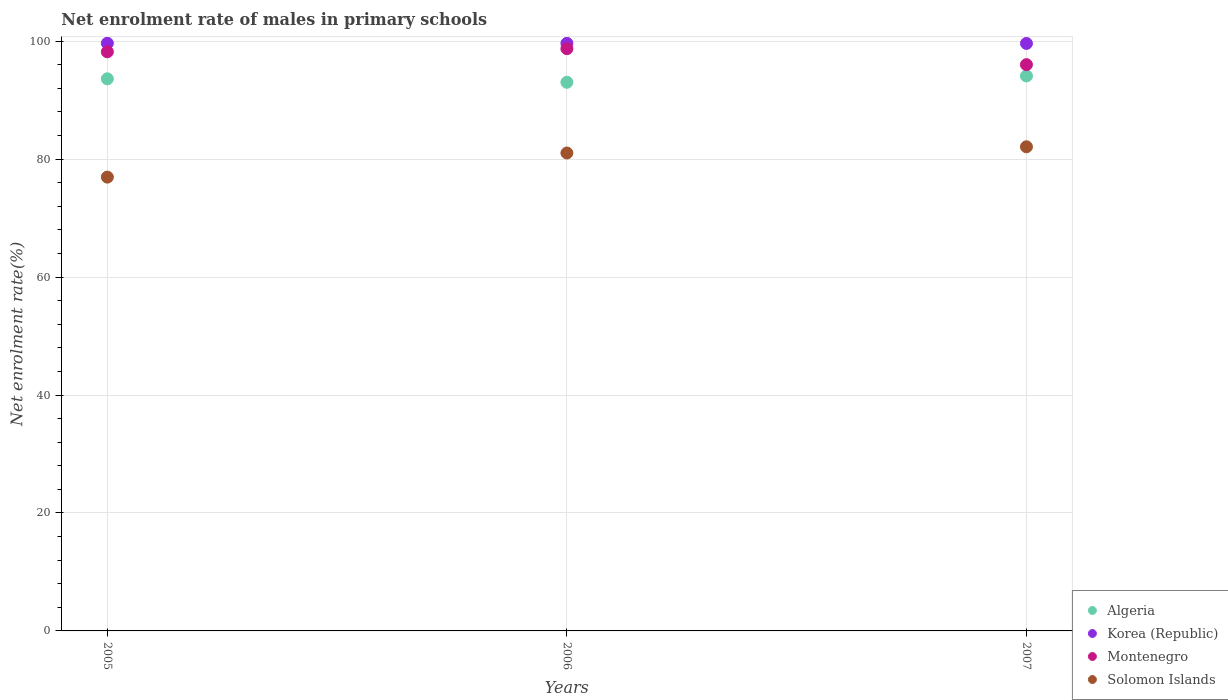How many different coloured dotlines are there?
Your answer should be very brief. 4. What is the net enrolment rate of males in primary schools in Algeria in 2006?
Ensure brevity in your answer.  93.03. Across all years, what is the maximum net enrolment rate of males in primary schools in Montenegro?
Keep it short and to the point. 98.73. Across all years, what is the minimum net enrolment rate of males in primary schools in Montenegro?
Make the answer very short. 96.02. In which year was the net enrolment rate of males in primary schools in Montenegro maximum?
Give a very brief answer. 2006. What is the total net enrolment rate of males in primary schools in Solomon Islands in the graph?
Offer a very short reply. 240.09. What is the difference between the net enrolment rate of males in primary schools in Solomon Islands in 2005 and that in 2006?
Your answer should be compact. -4.09. What is the difference between the net enrolment rate of males in primary schools in Algeria in 2006 and the net enrolment rate of males in primary schools in Solomon Islands in 2005?
Your answer should be very brief. 16.08. What is the average net enrolment rate of males in primary schools in Algeria per year?
Make the answer very short. 93.59. In the year 2006, what is the difference between the net enrolment rate of males in primary schools in Algeria and net enrolment rate of males in primary schools in Solomon Islands?
Make the answer very short. 11.99. In how many years, is the net enrolment rate of males in primary schools in Korea (Republic) greater than 20 %?
Your answer should be very brief. 3. What is the ratio of the net enrolment rate of males in primary schools in Korea (Republic) in 2005 to that in 2007?
Your answer should be very brief. 1. Is the net enrolment rate of males in primary schools in Algeria in 2005 less than that in 2006?
Offer a very short reply. No. Is the difference between the net enrolment rate of males in primary schools in Algeria in 2005 and 2007 greater than the difference between the net enrolment rate of males in primary schools in Solomon Islands in 2005 and 2007?
Offer a terse response. Yes. What is the difference between the highest and the second highest net enrolment rate of males in primary schools in Solomon Islands?
Make the answer very short. 1.05. What is the difference between the highest and the lowest net enrolment rate of males in primary schools in Korea (Republic)?
Provide a succinct answer. 0.03. Is the net enrolment rate of males in primary schools in Algeria strictly greater than the net enrolment rate of males in primary schools in Korea (Republic) over the years?
Offer a very short reply. No. Is the net enrolment rate of males in primary schools in Algeria strictly less than the net enrolment rate of males in primary schools in Montenegro over the years?
Make the answer very short. Yes. How many years are there in the graph?
Offer a very short reply. 3. How are the legend labels stacked?
Offer a very short reply. Vertical. What is the title of the graph?
Make the answer very short. Net enrolment rate of males in primary schools. Does "Heavily indebted poor countries" appear as one of the legend labels in the graph?
Give a very brief answer. No. What is the label or title of the Y-axis?
Offer a very short reply. Net enrolment rate(%). What is the Net enrolment rate(%) of Algeria in 2005?
Your answer should be compact. 93.62. What is the Net enrolment rate(%) in Korea (Republic) in 2005?
Provide a short and direct response. 99.65. What is the Net enrolment rate(%) in Montenegro in 2005?
Provide a short and direct response. 98.2. What is the Net enrolment rate(%) of Solomon Islands in 2005?
Your answer should be very brief. 76.95. What is the Net enrolment rate(%) in Algeria in 2006?
Make the answer very short. 93.03. What is the Net enrolment rate(%) in Korea (Republic) in 2006?
Your answer should be very brief. 99.64. What is the Net enrolment rate(%) of Montenegro in 2006?
Make the answer very short. 98.73. What is the Net enrolment rate(%) in Solomon Islands in 2006?
Ensure brevity in your answer.  81.04. What is the Net enrolment rate(%) of Algeria in 2007?
Keep it short and to the point. 94.11. What is the Net enrolment rate(%) in Korea (Republic) in 2007?
Offer a very short reply. 99.62. What is the Net enrolment rate(%) of Montenegro in 2007?
Your response must be concise. 96.02. What is the Net enrolment rate(%) in Solomon Islands in 2007?
Keep it short and to the point. 82.1. Across all years, what is the maximum Net enrolment rate(%) of Algeria?
Keep it short and to the point. 94.11. Across all years, what is the maximum Net enrolment rate(%) of Korea (Republic)?
Make the answer very short. 99.65. Across all years, what is the maximum Net enrolment rate(%) in Montenegro?
Make the answer very short. 98.73. Across all years, what is the maximum Net enrolment rate(%) of Solomon Islands?
Offer a very short reply. 82.1. Across all years, what is the minimum Net enrolment rate(%) of Algeria?
Your answer should be very brief. 93.03. Across all years, what is the minimum Net enrolment rate(%) of Korea (Republic)?
Your answer should be very brief. 99.62. Across all years, what is the minimum Net enrolment rate(%) of Montenegro?
Provide a short and direct response. 96.02. Across all years, what is the minimum Net enrolment rate(%) of Solomon Islands?
Provide a short and direct response. 76.95. What is the total Net enrolment rate(%) in Algeria in the graph?
Provide a short and direct response. 280.76. What is the total Net enrolment rate(%) of Korea (Republic) in the graph?
Ensure brevity in your answer.  298.91. What is the total Net enrolment rate(%) of Montenegro in the graph?
Offer a terse response. 292.96. What is the total Net enrolment rate(%) of Solomon Islands in the graph?
Give a very brief answer. 240.09. What is the difference between the Net enrolment rate(%) of Algeria in 2005 and that in 2006?
Your answer should be very brief. 0.59. What is the difference between the Net enrolment rate(%) of Korea (Republic) in 2005 and that in 2006?
Provide a succinct answer. 0.01. What is the difference between the Net enrolment rate(%) of Montenegro in 2005 and that in 2006?
Offer a very short reply. -0.53. What is the difference between the Net enrolment rate(%) of Solomon Islands in 2005 and that in 2006?
Keep it short and to the point. -4.09. What is the difference between the Net enrolment rate(%) in Algeria in 2005 and that in 2007?
Make the answer very short. -0.48. What is the difference between the Net enrolment rate(%) of Korea (Republic) in 2005 and that in 2007?
Provide a succinct answer. 0.03. What is the difference between the Net enrolment rate(%) of Montenegro in 2005 and that in 2007?
Ensure brevity in your answer.  2.18. What is the difference between the Net enrolment rate(%) of Solomon Islands in 2005 and that in 2007?
Provide a succinct answer. -5.14. What is the difference between the Net enrolment rate(%) of Algeria in 2006 and that in 2007?
Provide a succinct answer. -1.07. What is the difference between the Net enrolment rate(%) of Korea (Republic) in 2006 and that in 2007?
Provide a succinct answer. 0.02. What is the difference between the Net enrolment rate(%) in Montenegro in 2006 and that in 2007?
Offer a terse response. 2.71. What is the difference between the Net enrolment rate(%) in Solomon Islands in 2006 and that in 2007?
Your answer should be compact. -1.05. What is the difference between the Net enrolment rate(%) in Algeria in 2005 and the Net enrolment rate(%) in Korea (Republic) in 2006?
Provide a short and direct response. -6.02. What is the difference between the Net enrolment rate(%) of Algeria in 2005 and the Net enrolment rate(%) of Montenegro in 2006?
Your response must be concise. -5.11. What is the difference between the Net enrolment rate(%) of Algeria in 2005 and the Net enrolment rate(%) of Solomon Islands in 2006?
Your response must be concise. 12.58. What is the difference between the Net enrolment rate(%) in Korea (Republic) in 2005 and the Net enrolment rate(%) in Montenegro in 2006?
Your answer should be very brief. 0.91. What is the difference between the Net enrolment rate(%) of Korea (Republic) in 2005 and the Net enrolment rate(%) of Solomon Islands in 2006?
Your answer should be compact. 18.61. What is the difference between the Net enrolment rate(%) of Montenegro in 2005 and the Net enrolment rate(%) of Solomon Islands in 2006?
Give a very brief answer. 17.16. What is the difference between the Net enrolment rate(%) of Algeria in 2005 and the Net enrolment rate(%) of Korea (Republic) in 2007?
Offer a very short reply. -6. What is the difference between the Net enrolment rate(%) of Algeria in 2005 and the Net enrolment rate(%) of Montenegro in 2007?
Your answer should be compact. -2.4. What is the difference between the Net enrolment rate(%) of Algeria in 2005 and the Net enrolment rate(%) of Solomon Islands in 2007?
Offer a very short reply. 11.53. What is the difference between the Net enrolment rate(%) of Korea (Republic) in 2005 and the Net enrolment rate(%) of Montenegro in 2007?
Make the answer very short. 3.62. What is the difference between the Net enrolment rate(%) of Korea (Republic) in 2005 and the Net enrolment rate(%) of Solomon Islands in 2007?
Your response must be concise. 17.55. What is the difference between the Net enrolment rate(%) in Montenegro in 2005 and the Net enrolment rate(%) in Solomon Islands in 2007?
Offer a very short reply. 16.11. What is the difference between the Net enrolment rate(%) of Algeria in 2006 and the Net enrolment rate(%) of Korea (Republic) in 2007?
Give a very brief answer. -6.59. What is the difference between the Net enrolment rate(%) of Algeria in 2006 and the Net enrolment rate(%) of Montenegro in 2007?
Your response must be concise. -2.99. What is the difference between the Net enrolment rate(%) in Algeria in 2006 and the Net enrolment rate(%) in Solomon Islands in 2007?
Your response must be concise. 10.94. What is the difference between the Net enrolment rate(%) in Korea (Republic) in 2006 and the Net enrolment rate(%) in Montenegro in 2007?
Your answer should be very brief. 3.61. What is the difference between the Net enrolment rate(%) in Korea (Republic) in 2006 and the Net enrolment rate(%) in Solomon Islands in 2007?
Offer a terse response. 17.54. What is the difference between the Net enrolment rate(%) in Montenegro in 2006 and the Net enrolment rate(%) in Solomon Islands in 2007?
Your answer should be compact. 16.64. What is the average Net enrolment rate(%) of Algeria per year?
Keep it short and to the point. 93.59. What is the average Net enrolment rate(%) of Korea (Republic) per year?
Provide a succinct answer. 99.64. What is the average Net enrolment rate(%) of Montenegro per year?
Keep it short and to the point. 97.65. What is the average Net enrolment rate(%) in Solomon Islands per year?
Provide a short and direct response. 80.03. In the year 2005, what is the difference between the Net enrolment rate(%) of Algeria and Net enrolment rate(%) of Korea (Republic)?
Provide a succinct answer. -6.03. In the year 2005, what is the difference between the Net enrolment rate(%) in Algeria and Net enrolment rate(%) in Montenegro?
Provide a short and direct response. -4.58. In the year 2005, what is the difference between the Net enrolment rate(%) in Algeria and Net enrolment rate(%) in Solomon Islands?
Your response must be concise. 16.67. In the year 2005, what is the difference between the Net enrolment rate(%) of Korea (Republic) and Net enrolment rate(%) of Montenegro?
Your answer should be compact. 1.45. In the year 2005, what is the difference between the Net enrolment rate(%) in Korea (Republic) and Net enrolment rate(%) in Solomon Islands?
Your answer should be compact. 22.7. In the year 2005, what is the difference between the Net enrolment rate(%) of Montenegro and Net enrolment rate(%) of Solomon Islands?
Make the answer very short. 21.25. In the year 2006, what is the difference between the Net enrolment rate(%) in Algeria and Net enrolment rate(%) in Korea (Republic)?
Your answer should be compact. -6.6. In the year 2006, what is the difference between the Net enrolment rate(%) in Algeria and Net enrolment rate(%) in Montenegro?
Make the answer very short. -5.7. In the year 2006, what is the difference between the Net enrolment rate(%) of Algeria and Net enrolment rate(%) of Solomon Islands?
Provide a succinct answer. 11.99. In the year 2006, what is the difference between the Net enrolment rate(%) in Korea (Republic) and Net enrolment rate(%) in Montenegro?
Make the answer very short. 0.9. In the year 2006, what is the difference between the Net enrolment rate(%) in Korea (Republic) and Net enrolment rate(%) in Solomon Islands?
Offer a terse response. 18.6. In the year 2006, what is the difference between the Net enrolment rate(%) of Montenegro and Net enrolment rate(%) of Solomon Islands?
Give a very brief answer. 17.69. In the year 2007, what is the difference between the Net enrolment rate(%) in Algeria and Net enrolment rate(%) in Korea (Republic)?
Offer a very short reply. -5.51. In the year 2007, what is the difference between the Net enrolment rate(%) of Algeria and Net enrolment rate(%) of Montenegro?
Your answer should be compact. -1.92. In the year 2007, what is the difference between the Net enrolment rate(%) of Algeria and Net enrolment rate(%) of Solomon Islands?
Your answer should be very brief. 12.01. In the year 2007, what is the difference between the Net enrolment rate(%) of Korea (Republic) and Net enrolment rate(%) of Montenegro?
Your answer should be very brief. 3.6. In the year 2007, what is the difference between the Net enrolment rate(%) in Korea (Republic) and Net enrolment rate(%) in Solomon Islands?
Give a very brief answer. 17.52. In the year 2007, what is the difference between the Net enrolment rate(%) of Montenegro and Net enrolment rate(%) of Solomon Islands?
Offer a terse response. 13.93. What is the ratio of the Net enrolment rate(%) of Korea (Republic) in 2005 to that in 2006?
Provide a short and direct response. 1. What is the ratio of the Net enrolment rate(%) in Solomon Islands in 2005 to that in 2006?
Provide a short and direct response. 0.95. What is the ratio of the Net enrolment rate(%) of Algeria in 2005 to that in 2007?
Give a very brief answer. 0.99. What is the ratio of the Net enrolment rate(%) of Montenegro in 2005 to that in 2007?
Your response must be concise. 1.02. What is the ratio of the Net enrolment rate(%) of Solomon Islands in 2005 to that in 2007?
Keep it short and to the point. 0.94. What is the ratio of the Net enrolment rate(%) of Algeria in 2006 to that in 2007?
Your answer should be very brief. 0.99. What is the ratio of the Net enrolment rate(%) of Montenegro in 2006 to that in 2007?
Offer a terse response. 1.03. What is the ratio of the Net enrolment rate(%) of Solomon Islands in 2006 to that in 2007?
Offer a very short reply. 0.99. What is the difference between the highest and the second highest Net enrolment rate(%) in Algeria?
Offer a terse response. 0.48. What is the difference between the highest and the second highest Net enrolment rate(%) of Korea (Republic)?
Provide a short and direct response. 0.01. What is the difference between the highest and the second highest Net enrolment rate(%) in Montenegro?
Make the answer very short. 0.53. What is the difference between the highest and the second highest Net enrolment rate(%) in Solomon Islands?
Ensure brevity in your answer.  1.05. What is the difference between the highest and the lowest Net enrolment rate(%) of Algeria?
Give a very brief answer. 1.07. What is the difference between the highest and the lowest Net enrolment rate(%) of Korea (Republic)?
Provide a succinct answer. 0.03. What is the difference between the highest and the lowest Net enrolment rate(%) in Montenegro?
Offer a very short reply. 2.71. What is the difference between the highest and the lowest Net enrolment rate(%) in Solomon Islands?
Ensure brevity in your answer.  5.14. 